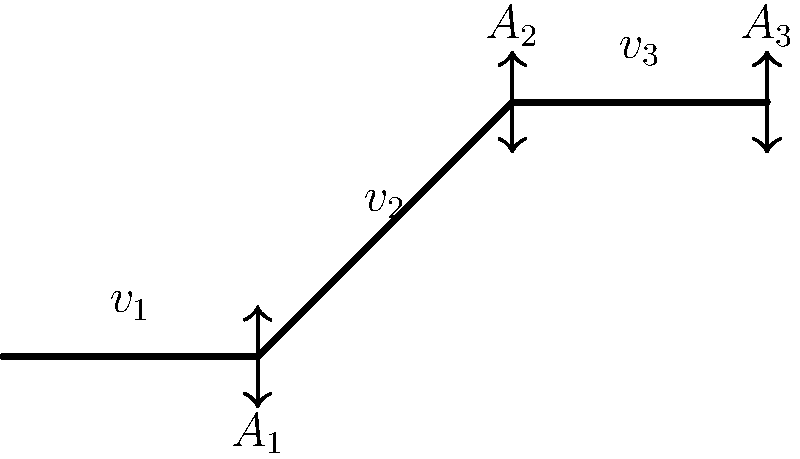In the pipe shown above, the cross-sectional areas at points 1, 2, and 3 are $A_1$, $A_2$, and $A_3$ respectively. If $A_1 = 100 \text{ cm}^2$, $A_2 = 50 \text{ cm}^2$, and $A_3 = 75 \text{ cm}^2$, and the velocity at point 1 is $v_1 = 2 \text{ m/s}$, calculate the velocity at point 3 ($v_3$) assuming the fluid is incompressible. To solve this problem, we'll use the principle of continuity for incompressible fluids. The steps are as follows:

1) The continuity equation states that for an incompressible fluid, the mass flow rate is constant throughout the pipe. This can be expressed as:

   $$A_1v_1 = A_2v_2 = A_3v_3$$

2) We know $A_1$, $A_3$, and $v_1$. We need to find $v_3$. Let's use the relationship between points 1 and 3:

   $$A_1v_1 = A_3v_3$$

3) Substitute the known values:

   $$100 \text{ cm}^2 \cdot 2 \text{ m/s} = 75 \text{ cm}^2 \cdot v_3$$

4) Solve for $v_3$:

   $$v_3 = \frac{100 \text{ cm}^2 \cdot 2 \text{ m/s}}{75 \text{ cm}^2} = \frac{200}{75} \text{ m/s}$$

5) Simplify:

   $$v_3 = \frac{8}{3} \text{ m/s} \approx 2.67 \text{ m/s}$$

Therefore, the velocity at point 3 is $\frac{8}{3} \text{ m/s}$ or approximately 2.67 m/s.
Answer: $\frac{8}{3} \text{ m/s}$ 